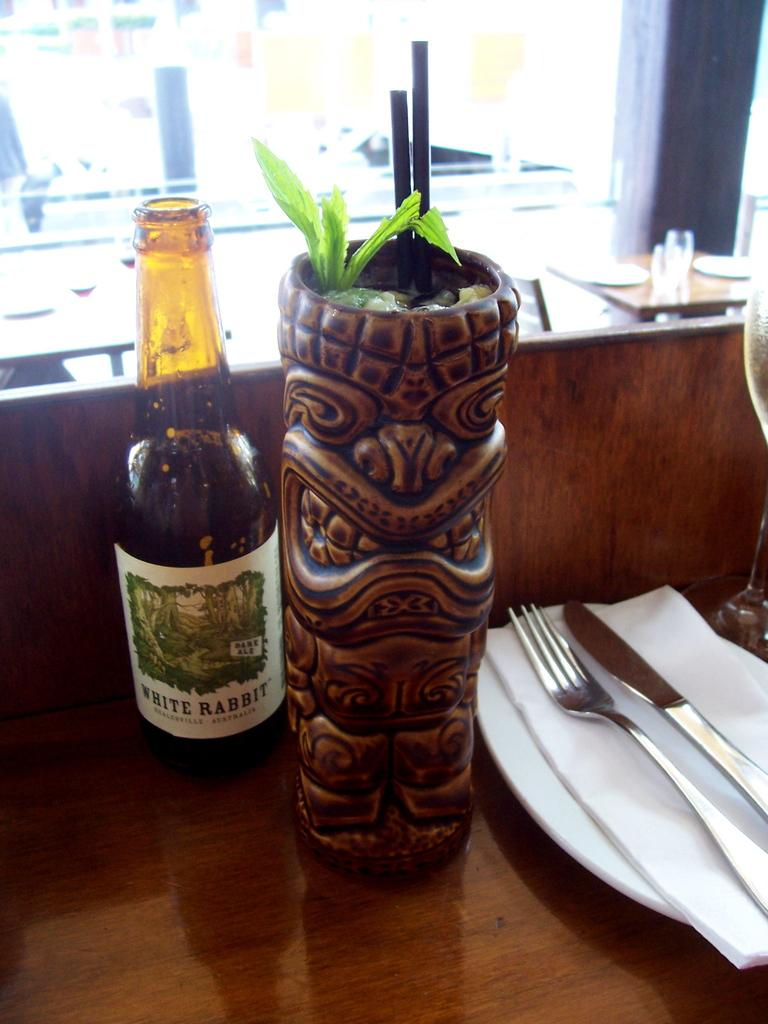Provide a one-sentence caption for the provided image. Bottle of white rabbit mixed drink with two straws inside it. 